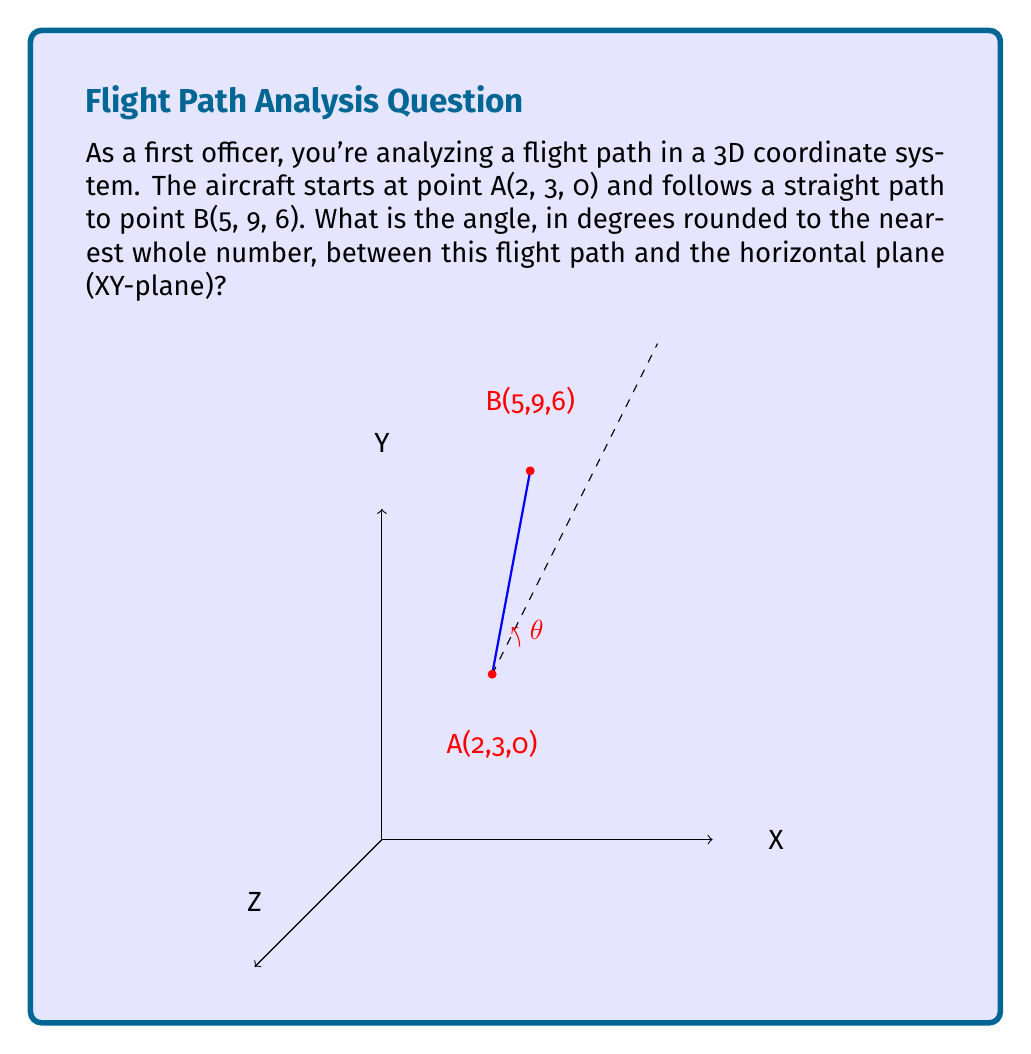Can you solve this math problem? To find the angle between the flight path and the horizontal plane, we can follow these steps:

1) First, let's calculate the vector $\vec{AB}$:
   $\vec{AB} = B - A = (5-2, 9-3, 6-0) = (3, 6, 6)$

2) The angle we're looking for is between this vector and its projection onto the XY-plane. The projection simply ignores the Z-component: $(3, 6, 0)$

3) We can find the angle using the dot product formula:
   $$\cos \theta = \frac{\vec{a} \cdot \vec{b}}{|\vec{a}||\vec{b}|}$$

   Where $\vec{a}$ is $\vec{AB}$ and $\vec{b}$ is its projection.

4) Calculate the dot product:
   $\vec{a} \cdot \vec{b} = 3(3) + 6(6) + 6(0) = 45$

5) Calculate the magnitudes:
   $|\vec{a}| = \sqrt{3^2 + 6^2 + 6^2} = \sqrt{81} = 9$
   $|\vec{b}| = \sqrt{3^2 + 6^2} = \sqrt{45} = 3\sqrt{5}$

6) Plug into the formula:
   $$\cos \theta = \frac{45}{9(3\sqrt{5})} = \frac{5}{3\sqrt{5}}$$

7) Take the inverse cosine (arccos) of both sides:
   $$\theta = \arccos(\frac{5}{3\sqrt{5}})$$

8) Calculate and round to the nearest whole number:
   $\theta \approx 41°$
Answer: $41°$ 